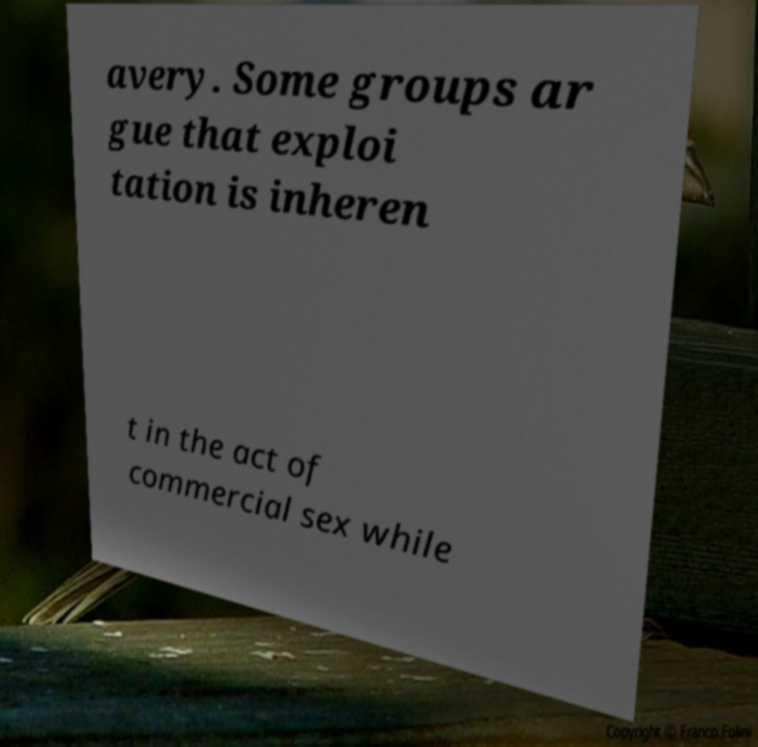Could you extract and type out the text from this image? avery. Some groups ar gue that exploi tation is inheren t in the act of commercial sex while 